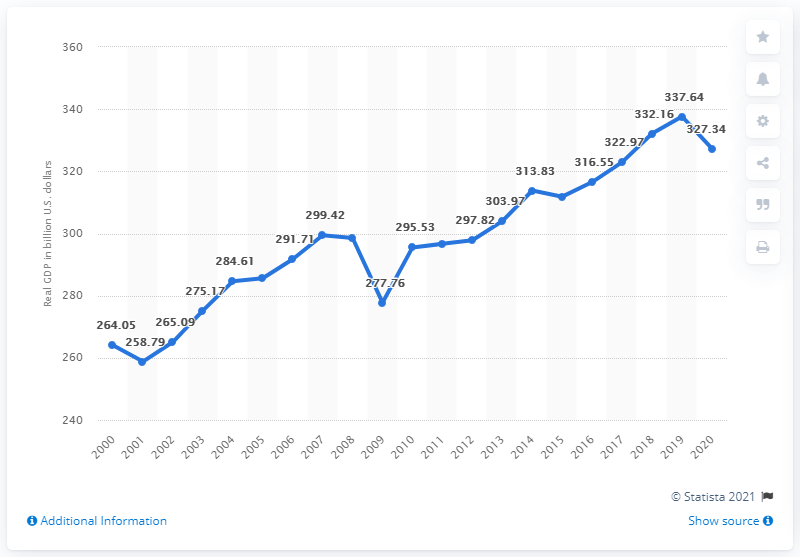Indicate a few pertinent items in this graphic. In 2018, the Gross Domestic Product (GDP) of the state of Indiana was estimated to be 337.64 billion dollars. In 2020, the estimated Gross Domestic Product (GDP) of the state of Indiana was 327.34 billion dollars. 